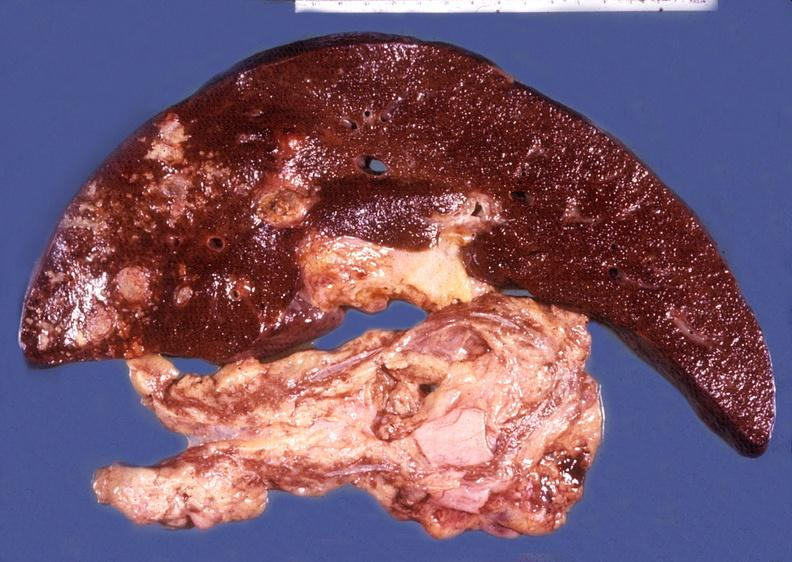s nipple duplication present?
Answer the question using a single word or phrase. No 